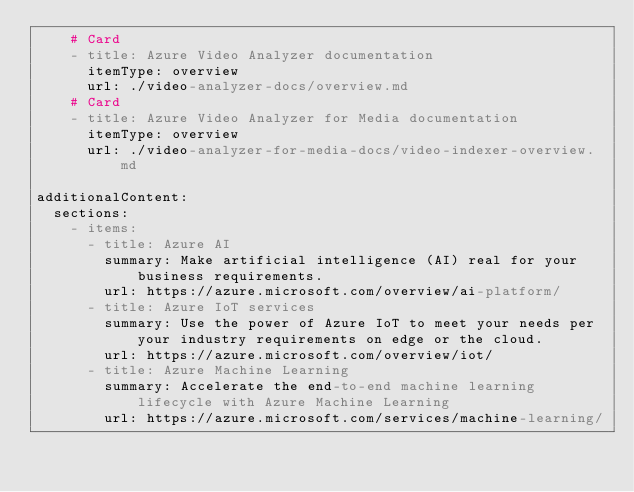<code> <loc_0><loc_0><loc_500><loc_500><_YAML_>    # Card
    - title: Azure Video Analyzer documentation
      itemType: overview
      url: ./video-analyzer-docs/overview.md 
    # Card
    - title: Azure Video Analyzer for Media documentation
      itemType: overview
      url: ./video-analyzer-for-media-docs/video-indexer-overview.md

additionalContent:
  sections:
    - items:      
      - title: Azure AI
        summary: Make artificial intelligence (AI) real for your business requirements.
        url: https://azure.microsoft.com/overview/ai-platform/
      - title: Azure IoT services
        summary: Use the power of Azure IoT to meet your needs per your industry requirements on edge or the cloud.
        url: https://azure.microsoft.com/overview/iot/
      - title: Azure Machine Learning
        summary: Accelerate the end-to-end machine learning lifecycle with Azure Machine Learning
        url: https://azure.microsoft.com/services/machine-learning/
</code> 